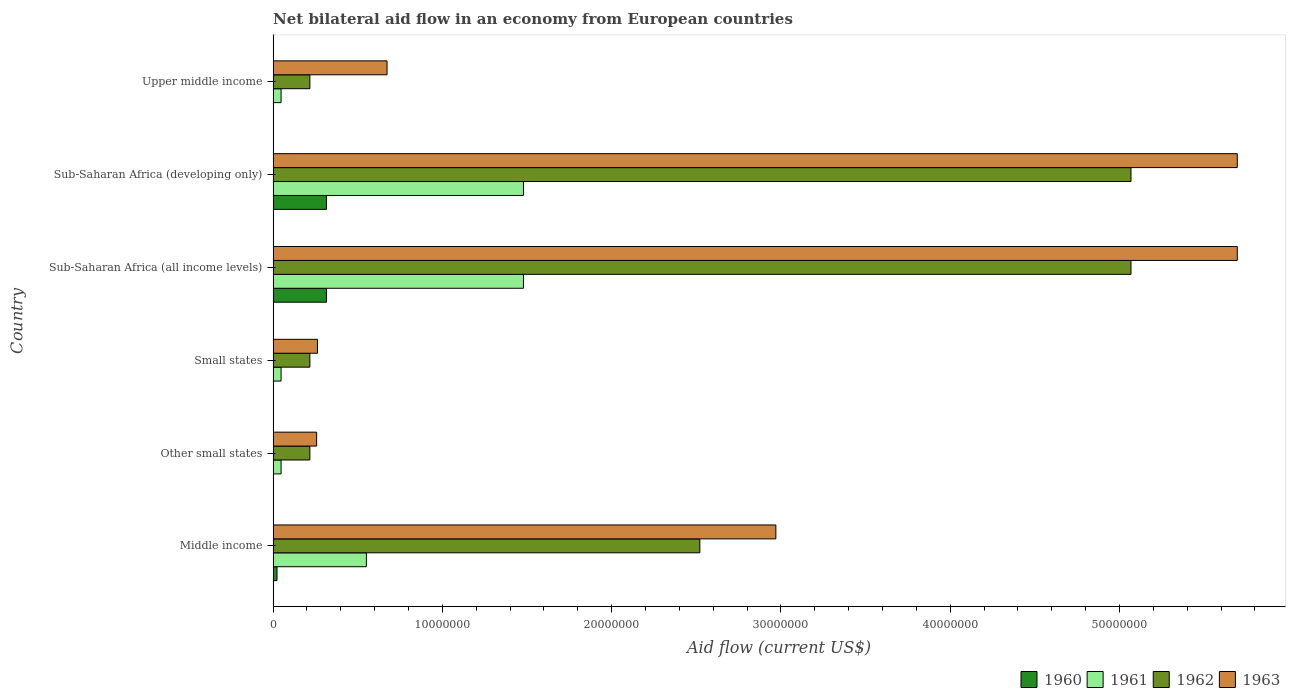How many groups of bars are there?
Give a very brief answer. 6. How many bars are there on the 4th tick from the top?
Give a very brief answer. 4. How many bars are there on the 6th tick from the bottom?
Ensure brevity in your answer.  4. What is the label of the 3rd group of bars from the top?
Offer a terse response. Sub-Saharan Africa (all income levels). In how many cases, is the number of bars for a given country not equal to the number of legend labels?
Your answer should be very brief. 0. What is the net bilateral aid flow in 1963 in Upper middle income?
Give a very brief answer. 6.73e+06. Across all countries, what is the maximum net bilateral aid flow in 1963?
Your response must be concise. 5.70e+07. Across all countries, what is the minimum net bilateral aid flow in 1963?
Provide a succinct answer. 2.57e+06. In which country was the net bilateral aid flow in 1960 maximum?
Provide a succinct answer. Sub-Saharan Africa (all income levels). In which country was the net bilateral aid flow in 1962 minimum?
Offer a terse response. Other small states. What is the total net bilateral aid flow in 1962 in the graph?
Ensure brevity in your answer.  1.33e+08. What is the difference between the net bilateral aid flow in 1960 in Middle income and that in Small states?
Give a very brief answer. 2.20e+05. What is the difference between the net bilateral aid flow in 1960 in Sub-Saharan Africa (all income levels) and the net bilateral aid flow in 1963 in Middle income?
Give a very brief answer. -2.66e+07. What is the average net bilateral aid flow in 1960 per country?
Offer a terse response. 1.09e+06. What is the difference between the net bilateral aid flow in 1962 and net bilateral aid flow in 1961 in Small states?
Provide a short and direct response. 1.70e+06. In how many countries, is the net bilateral aid flow in 1963 greater than 30000000 US$?
Your answer should be very brief. 2. What is the ratio of the net bilateral aid flow in 1963 in Other small states to that in Sub-Saharan Africa (all income levels)?
Offer a terse response. 0.05. Is the net bilateral aid flow in 1963 in Other small states less than that in Upper middle income?
Offer a very short reply. Yes. What is the difference between the highest and the second highest net bilateral aid flow in 1961?
Offer a very short reply. 0. What is the difference between the highest and the lowest net bilateral aid flow in 1963?
Offer a very short reply. 5.44e+07. In how many countries, is the net bilateral aid flow in 1960 greater than the average net bilateral aid flow in 1960 taken over all countries?
Provide a short and direct response. 2. Is the sum of the net bilateral aid flow in 1961 in Middle income and Other small states greater than the maximum net bilateral aid flow in 1960 across all countries?
Your answer should be compact. Yes. Is it the case that in every country, the sum of the net bilateral aid flow in 1961 and net bilateral aid flow in 1963 is greater than the sum of net bilateral aid flow in 1962 and net bilateral aid flow in 1960?
Give a very brief answer. No. What does the 2nd bar from the bottom in Upper middle income represents?
Give a very brief answer. 1961. Is it the case that in every country, the sum of the net bilateral aid flow in 1963 and net bilateral aid flow in 1962 is greater than the net bilateral aid flow in 1960?
Your answer should be compact. Yes. How many bars are there?
Keep it short and to the point. 24. Are all the bars in the graph horizontal?
Offer a very short reply. Yes. Are the values on the major ticks of X-axis written in scientific E-notation?
Keep it short and to the point. No. Does the graph contain grids?
Keep it short and to the point. No. Where does the legend appear in the graph?
Give a very brief answer. Bottom right. What is the title of the graph?
Offer a terse response. Net bilateral aid flow in an economy from European countries. Does "1979" appear as one of the legend labels in the graph?
Keep it short and to the point. No. What is the label or title of the X-axis?
Your answer should be compact. Aid flow (current US$). What is the label or title of the Y-axis?
Give a very brief answer. Country. What is the Aid flow (current US$) of 1960 in Middle income?
Make the answer very short. 2.30e+05. What is the Aid flow (current US$) of 1961 in Middle income?
Your response must be concise. 5.51e+06. What is the Aid flow (current US$) of 1962 in Middle income?
Provide a short and direct response. 2.52e+07. What is the Aid flow (current US$) of 1963 in Middle income?
Offer a very short reply. 2.97e+07. What is the Aid flow (current US$) of 1960 in Other small states?
Provide a succinct answer. 10000. What is the Aid flow (current US$) in 1962 in Other small states?
Give a very brief answer. 2.17e+06. What is the Aid flow (current US$) of 1963 in Other small states?
Offer a terse response. 2.57e+06. What is the Aid flow (current US$) of 1962 in Small states?
Your response must be concise. 2.17e+06. What is the Aid flow (current US$) in 1963 in Small states?
Provide a short and direct response. 2.62e+06. What is the Aid flow (current US$) in 1960 in Sub-Saharan Africa (all income levels)?
Make the answer very short. 3.15e+06. What is the Aid flow (current US$) of 1961 in Sub-Saharan Africa (all income levels)?
Keep it short and to the point. 1.48e+07. What is the Aid flow (current US$) of 1962 in Sub-Saharan Africa (all income levels)?
Keep it short and to the point. 5.07e+07. What is the Aid flow (current US$) in 1963 in Sub-Saharan Africa (all income levels)?
Your response must be concise. 5.70e+07. What is the Aid flow (current US$) of 1960 in Sub-Saharan Africa (developing only)?
Make the answer very short. 3.15e+06. What is the Aid flow (current US$) in 1961 in Sub-Saharan Africa (developing only)?
Ensure brevity in your answer.  1.48e+07. What is the Aid flow (current US$) of 1962 in Sub-Saharan Africa (developing only)?
Offer a very short reply. 5.07e+07. What is the Aid flow (current US$) of 1963 in Sub-Saharan Africa (developing only)?
Offer a very short reply. 5.70e+07. What is the Aid flow (current US$) of 1961 in Upper middle income?
Offer a terse response. 4.70e+05. What is the Aid flow (current US$) in 1962 in Upper middle income?
Your answer should be very brief. 2.17e+06. What is the Aid flow (current US$) of 1963 in Upper middle income?
Ensure brevity in your answer.  6.73e+06. Across all countries, what is the maximum Aid flow (current US$) of 1960?
Offer a terse response. 3.15e+06. Across all countries, what is the maximum Aid flow (current US$) in 1961?
Keep it short and to the point. 1.48e+07. Across all countries, what is the maximum Aid flow (current US$) of 1962?
Give a very brief answer. 5.07e+07. Across all countries, what is the maximum Aid flow (current US$) of 1963?
Ensure brevity in your answer.  5.70e+07. Across all countries, what is the minimum Aid flow (current US$) of 1961?
Give a very brief answer. 4.70e+05. Across all countries, what is the minimum Aid flow (current US$) of 1962?
Give a very brief answer. 2.17e+06. Across all countries, what is the minimum Aid flow (current US$) of 1963?
Offer a terse response. 2.57e+06. What is the total Aid flow (current US$) of 1960 in the graph?
Provide a short and direct response. 6.56e+06. What is the total Aid flow (current US$) of 1961 in the graph?
Offer a very short reply. 3.65e+07. What is the total Aid flow (current US$) in 1962 in the graph?
Offer a terse response. 1.33e+08. What is the total Aid flow (current US$) in 1963 in the graph?
Provide a succinct answer. 1.56e+08. What is the difference between the Aid flow (current US$) of 1960 in Middle income and that in Other small states?
Offer a terse response. 2.20e+05. What is the difference between the Aid flow (current US$) in 1961 in Middle income and that in Other small states?
Your answer should be compact. 5.04e+06. What is the difference between the Aid flow (current US$) in 1962 in Middle income and that in Other small states?
Ensure brevity in your answer.  2.30e+07. What is the difference between the Aid flow (current US$) in 1963 in Middle income and that in Other small states?
Make the answer very short. 2.71e+07. What is the difference between the Aid flow (current US$) of 1961 in Middle income and that in Small states?
Your answer should be very brief. 5.04e+06. What is the difference between the Aid flow (current US$) of 1962 in Middle income and that in Small states?
Offer a very short reply. 2.30e+07. What is the difference between the Aid flow (current US$) in 1963 in Middle income and that in Small states?
Make the answer very short. 2.71e+07. What is the difference between the Aid flow (current US$) in 1960 in Middle income and that in Sub-Saharan Africa (all income levels)?
Make the answer very short. -2.92e+06. What is the difference between the Aid flow (current US$) of 1961 in Middle income and that in Sub-Saharan Africa (all income levels)?
Your response must be concise. -9.28e+06. What is the difference between the Aid flow (current US$) of 1962 in Middle income and that in Sub-Saharan Africa (all income levels)?
Ensure brevity in your answer.  -2.55e+07. What is the difference between the Aid flow (current US$) in 1963 in Middle income and that in Sub-Saharan Africa (all income levels)?
Keep it short and to the point. -2.73e+07. What is the difference between the Aid flow (current US$) of 1960 in Middle income and that in Sub-Saharan Africa (developing only)?
Provide a short and direct response. -2.92e+06. What is the difference between the Aid flow (current US$) of 1961 in Middle income and that in Sub-Saharan Africa (developing only)?
Offer a very short reply. -9.28e+06. What is the difference between the Aid flow (current US$) of 1962 in Middle income and that in Sub-Saharan Africa (developing only)?
Ensure brevity in your answer.  -2.55e+07. What is the difference between the Aid flow (current US$) in 1963 in Middle income and that in Sub-Saharan Africa (developing only)?
Offer a very short reply. -2.73e+07. What is the difference between the Aid flow (current US$) in 1961 in Middle income and that in Upper middle income?
Keep it short and to the point. 5.04e+06. What is the difference between the Aid flow (current US$) of 1962 in Middle income and that in Upper middle income?
Make the answer very short. 2.30e+07. What is the difference between the Aid flow (current US$) in 1963 in Middle income and that in Upper middle income?
Provide a succinct answer. 2.30e+07. What is the difference between the Aid flow (current US$) in 1960 in Other small states and that in Small states?
Make the answer very short. 0. What is the difference between the Aid flow (current US$) in 1962 in Other small states and that in Small states?
Your answer should be very brief. 0. What is the difference between the Aid flow (current US$) in 1963 in Other small states and that in Small states?
Offer a very short reply. -5.00e+04. What is the difference between the Aid flow (current US$) in 1960 in Other small states and that in Sub-Saharan Africa (all income levels)?
Your response must be concise. -3.14e+06. What is the difference between the Aid flow (current US$) in 1961 in Other small states and that in Sub-Saharan Africa (all income levels)?
Keep it short and to the point. -1.43e+07. What is the difference between the Aid flow (current US$) in 1962 in Other small states and that in Sub-Saharan Africa (all income levels)?
Offer a very short reply. -4.85e+07. What is the difference between the Aid flow (current US$) of 1963 in Other small states and that in Sub-Saharan Africa (all income levels)?
Ensure brevity in your answer.  -5.44e+07. What is the difference between the Aid flow (current US$) in 1960 in Other small states and that in Sub-Saharan Africa (developing only)?
Your answer should be very brief. -3.14e+06. What is the difference between the Aid flow (current US$) of 1961 in Other small states and that in Sub-Saharan Africa (developing only)?
Provide a succinct answer. -1.43e+07. What is the difference between the Aid flow (current US$) of 1962 in Other small states and that in Sub-Saharan Africa (developing only)?
Your response must be concise. -4.85e+07. What is the difference between the Aid flow (current US$) of 1963 in Other small states and that in Sub-Saharan Africa (developing only)?
Make the answer very short. -5.44e+07. What is the difference between the Aid flow (current US$) of 1963 in Other small states and that in Upper middle income?
Your answer should be compact. -4.16e+06. What is the difference between the Aid flow (current US$) of 1960 in Small states and that in Sub-Saharan Africa (all income levels)?
Provide a succinct answer. -3.14e+06. What is the difference between the Aid flow (current US$) in 1961 in Small states and that in Sub-Saharan Africa (all income levels)?
Make the answer very short. -1.43e+07. What is the difference between the Aid flow (current US$) in 1962 in Small states and that in Sub-Saharan Africa (all income levels)?
Your answer should be very brief. -4.85e+07. What is the difference between the Aid flow (current US$) of 1963 in Small states and that in Sub-Saharan Africa (all income levels)?
Offer a terse response. -5.43e+07. What is the difference between the Aid flow (current US$) of 1960 in Small states and that in Sub-Saharan Africa (developing only)?
Make the answer very short. -3.14e+06. What is the difference between the Aid flow (current US$) of 1961 in Small states and that in Sub-Saharan Africa (developing only)?
Your response must be concise. -1.43e+07. What is the difference between the Aid flow (current US$) in 1962 in Small states and that in Sub-Saharan Africa (developing only)?
Ensure brevity in your answer.  -4.85e+07. What is the difference between the Aid flow (current US$) in 1963 in Small states and that in Sub-Saharan Africa (developing only)?
Keep it short and to the point. -5.43e+07. What is the difference between the Aid flow (current US$) in 1960 in Small states and that in Upper middle income?
Offer a very short reply. 0. What is the difference between the Aid flow (current US$) in 1961 in Small states and that in Upper middle income?
Keep it short and to the point. 0. What is the difference between the Aid flow (current US$) of 1963 in Small states and that in Upper middle income?
Your answer should be compact. -4.11e+06. What is the difference between the Aid flow (current US$) in 1961 in Sub-Saharan Africa (all income levels) and that in Sub-Saharan Africa (developing only)?
Your answer should be compact. 0. What is the difference between the Aid flow (current US$) of 1962 in Sub-Saharan Africa (all income levels) and that in Sub-Saharan Africa (developing only)?
Ensure brevity in your answer.  0. What is the difference between the Aid flow (current US$) of 1963 in Sub-Saharan Africa (all income levels) and that in Sub-Saharan Africa (developing only)?
Give a very brief answer. 0. What is the difference between the Aid flow (current US$) in 1960 in Sub-Saharan Africa (all income levels) and that in Upper middle income?
Offer a terse response. 3.14e+06. What is the difference between the Aid flow (current US$) of 1961 in Sub-Saharan Africa (all income levels) and that in Upper middle income?
Ensure brevity in your answer.  1.43e+07. What is the difference between the Aid flow (current US$) of 1962 in Sub-Saharan Africa (all income levels) and that in Upper middle income?
Give a very brief answer. 4.85e+07. What is the difference between the Aid flow (current US$) in 1963 in Sub-Saharan Africa (all income levels) and that in Upper middle income?
Keep it short and to the point. 5.02e+07. What is the difference between the Aid flow (current US$) in 1960 in Sub-Saharan Africa (developing only) and that in Upper middle income?
Offer a very short reply. 3.14e+06. What is the difference between the Aid flow (current US$) in 1961 in Sub-Saharan Africa (developing only) and that in Upper middle income?
Provide a succinct answer. 1.43e+07. What is the difference between the Aid flow (current US$) in 1962 in Sub-Saharan Africa (developing only) and that in Upper middle income?
Keep it short and to the point. 4.85e+07. What is the difference between the Aid flow (current US$) in 1963 in Sub-Saharan Africa (developing only) and that in Upper middle income?
Your response must be concise. 5.02e+07. What is the difference between the Aid flow (current US$) in 1960 in Middle income and the Aid flow (current US$) in 1961 in Other small states?
Offer a terse response. -2.40e+05. What is the difference between the Aid flow (current US$) of 1960 in Middle income and the Aid flow (current US$) of 1962 in Other small states?
Ensure brevity in your answer.  -1.94e+06. What is the difference between the Aid flow (current US$) in 1960 in Middle income and the Aid flow (current US$) in 1963 in Other small states?
Offer a very short reply. -2.34e+06. What is the difference between the Aid flow (current US$) of 1961 in Middle income and the Aid flow (current US$) of 1962 in Other small states?
Ensure brevity in your answer.  3.34e+06. What is the difference between the Aid flow (current US$) in 1961 in Middle income and the Aid flow (current US$) in 1963 in Other small states?
Ensure brevity in your answer.  2.94e+06. What is the difference between the Aid flow (current US$) in 1962 in Middle income and the Aid flow (current US$) in 1963 in Other small states?
Your answer should be compact. 2.26e+07. What is the difference between the Aid flow (current US$) of 1960 in Middle income and the Aid flow (current US$) of 1962 in Small states?
Provide a succinct answer. -1.94e+06. What is the difference between the Aid flow (current US$) of 1960 in Middle income and the Aid flow (current US$) of 1963 in Small states?
Your answer should be compact. -2.39e+06. What is the difference between the Aid flow (current US$) in 1961 in Middle income and the Aid flow (current US$) in 1962 in Small states?
Give a very brief answer. 3.34e+06. What is the difference between the Aid flow (current US$) of 1961 in Middle income and the Aid flow (current US$) of 1963 in Small states?
Your response must be concise. 2.89e+06. What is the difference between the Aid flow (current US$) in 1962 in Middle income and the Aid flow (current US$) in 1963 in Small states?
Offer a very short reply. 2.26e+07. What is the difference between the Aid flow (current US$) in 1960 in Middle income and the Aid flow (current US$) in 1961 in Sub-Saharan Africa (all income levels)?
Provide a short and direct response. -1.46e+07. What is the difference between the Aid flow (current US$) in 1960 in Middle income and the Aid flow (current US$) in 1962 in Sub-Saharan Africa (all income levels)?
Offer a terse response. -5.04e+07. What is the difference between the Aid flow (current US$) of 1960 in Middle income and the Aid flow (current US$) of 1963 in Sub-Saharan Africa (all income levels)?
Offer a terse response. -5.67e+07. What is the difference between the Aid flow (current US$) in 1961 in Middle income and the Aid flow (current US$) in 1962 in Sub-Saharan Africa (all income levels)?
Provide a succinct answer. -4.52e+07. What is the difference between the Aid flow (current US$) of 1961 in Middle income and the Aid flow (current US$) of 1963 in Sub-Saharan Africa (all income levels)?
Provide a short and direct response. -5.14e+07. What is the difference between the Aid flow (current US$) in 1962 in Middle income and the Aid flow (current US$) in 1963 in Sub-Saharan Africa (all income levels)?
Your response must be concise. -3.18e+07. What is the difference between the Aid flow (current US$) in 1960 in Middle income and the Aid flow (current US$) in 1961 in Sub-Saharan Africa (developing only)?
Your response must be concise. -1.46e+07. What is the difference between the Aid flow (current US$) of 1960 in Middle income and the Aid flow (current US$) of 1962 in Sub-Saharan Africa (developing only)?
Keep it short and to the point. -5.04e+07. What is the difference between the Aid flow (current US$) in 1960 in Middle income and the Aid flow (current US$) in 1963 in Sub-Saharan Africa (developing only)?
Your answer should be compact. -5.67e+07. What is the difference between the Aid flow (current US$) in 1961 in Middle income and the Aid flow (current US$) in 1962 in Sub-Saharan Africa (developing only)?
Provide a succinct answer. -4.52e+07. What is the difference between the Aid flow (current US$) of 1961 in Middle income and the Aid flow (current US$) of 1963 in Sub-Saharan Africa (developing only)?
Offer a very short reply. -5.14e+07. What is the difference between the Aid flow (current US$) of 1962 in Middle income and the Aid flow (current US$) of 1963 in Sub-Saharan Africa (developing only)?
Your answer should be compact. -3.18e+07. What is the difference between the Aid flow (current US$) in 1960 in Middle income and the Aid flow (current US$) in 1961 in Upper middle income?
Keep it short and to the point. -2.40e+05. What is the difference between the Aid flow (current US$) of 1960 in Middle income and the Aid flow (current US$) of 1962 in Upper middle income?
Your answer should be very brief. -1.94e+06. What is the difference between the Aid flow (current US$) in 1960 in Middle income and the Aid flow (current US$) in 1963 in Upper middle income?
Your response must be concise. -6.50e+06. What is the difference between the Aid flow (current US$) in 1961 in Middle income and the Aid flow (current US$) in 1962 in Upper middle income?
Offer a terse response. 3.34e+06. What is the difference between the Aid flow (current US$) of 1961 in Middle income and the Aid flow (current US$) of 1963 in Upper middle income?
Give a very brief answer. -1.22e+06. What is the difference between the Aid flow (current US$) of 1962 in Middle income and the Aid flow (current US$) of 1963 in Upper middle income?
Your answer should be compact. 1.85e+07. What is the difference between the Aid flow (current US$) of 1960 in Other small states and the Aid flow (current US$) of 1961 in Small states?
Ensure brevity in your answer.  -4.60e+05. What is the difference between the Aid flow (current US$) in 1960 in Other small states and the Aid flow (current US$) in 1962 in Small states?
Offer a terse response. -2.16e+06. What is the difference between the Aid flow (current US$) of 1960 in Other small states and the Aid flow (current US$) of 1963 in Small states?
Your answer should be compact. -2.61e+06. What is the difference between the Aid flow (current US$) in 1961 in Other small states and the Aid flow (current US$) in 1962 in Small states?
Your response must be concise. -1.70e+06. What is the difference between the Aid flow (current US$) in 1961 in Other small states and the Aid flow (current US$) in 1963 in Small states?
Give a very brief answer. -2.15e+06. What is the difference between the Aid flow (current US$) in 1962 in Other small states and the Aid flow (current US$) in 1963 in Small states?
Provide a succinct answer. -4.50e+05. What is the difference between the Aid flow (current US$) of 1960 in Other small states and the Aid flow (current US$) of 1961 in Sub-Saharan Africa (all income levels)?
Your answer should be very brief. -1.48e+07. What is the difference between the Aid flow (current US$) in 1960 in Other small states and the Aid flow (current US$) in 1962 in Sub-Saharan Africa (all income levels)?
Provide a succinct answer. -5.07e+07. What is the difference between the Aid flow (current US$) in 1960 in Other small states and the Aid flow (current US$) in 1963 in Sub-Saharan Africa (all income levels)?
Keep it short and to the point. -5.70e+07. What is the difference between the Aid flow (current US$) of 1961 in Other small states and the Aid flow (current US$) of 1962 in Sub-Saharan Africa (all income levels)?
Offer a terse response. -5.02e+07. What is the difference between the Aid flow (current US$) in 1961 in Other small states and the Aid flow (current US$) in 1963 in Sub-Saharan Africa (all income levels)?
Keep it short and to the point. -5.65e+07. What is the difference between the Aid flow (current US$) in 1962 in Other small states and the Aid flow (current US$) in 1963 in Sub-Saharan Africa (all income levels)?
Provide a short and direct response. -5.48e+07. What is the difference between the Aid flow (current US$) in 1960 in Other small states and the Aid flow (current US$) in 1961 in Sub-Saharan Africa (developing only)?
Your answer should be very brief. -1.48e+07. What is the difference between the Aid flow (current US$) of 1960 in Other small states and the Aid flow (current US$) of 1962 in Sub-Saharan Africa (developing only)?
Your response must be concise. -5.07e+07. What is the difference between the Aid flow (current US$) of 1960 in Other small states and the Aid flow (current US$) of 1963 in Sub-Saharan Africa (developing only)?
Offer a very short reply. -5.70e+07. What is the difference between the Aid flow (current US$) of 1961 in Other small states and the Aid flow (current US$) of 1962 in Sub-Saharan Africa (developing only)?
Offer a very short reply. -5.02e+07. What is the difference between the Aid flow (current US$) in 1961 in Other small states and the Aid flow (current US$) in 1963 in Sub-Saharan Africa (developing only)?
Your response must be concise. -5.65e+07. What is the difference between the Aid flow (current US$) of 1962 in Other small states and the Aid flow (current US$) of 1963 in Sub-Saharan Africa (developing only)?
Give a very brief answer. -5.48e+07. What is the difference between the Aid flow (current US$) of 1960 in Other small states and the Aid flow (current US$) of 1961 in Upper middle income?
Provide a short and direct response. -4.60e+05. What is the difference between the Aid flow (current US$) of 1960 in Other small states and the Aid flow (current US$) of 1962 in Upper middle income?
Your answer should be compact. -2.16e+06. What is the difference between the Aid flow (current US$) of 1960 in Other small states and the Aid flow (current US$) of 1963 in Upper middle income?
Keep it short and to the point. -6.72e+06. What is the difference between the Aid flow (current US$) of 1961 in Other small states and the Aid flow (current US$) of 1962 in Upper middle income?
Ensure brevity in your answer.  -1.70e+06. What is the difference between the Aid flow (current US$) of 1961 in Other small states and the Aid flow (current US$) of 1963 in Upper middle income?
Offer a very short reply. -6.26e+06. What is the difference between the Aid flow (current US$) in 1962 in Other small states and the Aid flow (current US$) in 1963 in Upper middle income?
Provide a short and direct response. -4.56e+06. What is the difference between the Aid flow (current US$) in 1960 in Small states and the Aid flow (current US$) in 1961 in Sub-Saharan Africa (all income levels)?
Your response must be concise. -1.48e+07. What is the difference between the Aid flow (current US$) in 1960 in Small states and the Aid flow (current US$) in 1962 in Sub-Saharan Africa (all income levels)?
Provide a short and direct response. -5.07e+07. What is the difference between the Aid flow (current US$) of 1960 in Small states and the Aid flow (current US$) of 1963 in Sub-Saharan Africa (all income levels)?
Keep it short and to the point. -5.70e+07. What is the difference between the Aid flow (current US$) in 1961 in Small states and the Aid flow (current US$) in 1962 in Sub-Saharan Africa (all income levels)?
Provide a short and direct response. -5.02e+07. What is the difference between the Aid flow (current US$) of 1961 in Small states and the Aid flow (current US$) of 1963 in Sub-Saharan Africa (all income levels)?
Give a very brief answer. -5.65e+07. What is the difference between the Aid flow (current US$) of 1962 in Small states and the Aid flow (current US$) of 1963 in Sub-Saharan Africa (all income levels)?
Ensure brevity in your answer.  -5.48e+07. What is the difference between the Aid flow (current US$) of 1960 in Small states and the Aid flow (current US$) of 1961 in Sub-Saharan Africa (developing only)?
Ensure brevity in your answer.  -1.48e+07. What is the difference between the Aid flow (current US$) of 1960 in Small states and the Aid flow (current US$) of 1962 in Sub-Saharan Africa (developing only)?
Provide a succinct answer. -5.07e+07. What is the difference between the Aid flow (current US$) of 1960 in Small states and the Aid flow (current US$) of 1963 in Sub-Saharan Africa (developing only)?
Give a very brief answer. -5.70e+07. What is the difference between the Aid flow (current US$) in 1961 in Small states and the Aid flow (current US$) in 1962 in Sub-Saharan Africa (developing only)?
Give a very brief answer. -5.02e+07. What is the difference between the Aid flow (current US$) in 1961 in Small states and the Aid flow (current US$) in 1963 in Sub-Saharan Africa (developing only)?
Offer a very short reply. -5.65e+07. What is the difference between the Aid flow (current US$) of 1962 in Small states and the Aid flow (current US$) of 1963 in Sub-Saharan Africa (developing only)?
Make the answer very short. -5.48e+07. What is the difference between the Aid flow (current US$) in 1960 in Small states and the Aid flow (current US$) in 1961 in Upper middle income?
Offer a terse response. -4.60e+05. What is the difference between the Aid flow (current US$) of 1960 in Small states and the Aid flow (current US$) of 1962 in Upper middle income?
Your answer should be very brief. -2.16e+06. What is the difference between the Aid flow (current US$) in 1960 in Small states and the Aid flow (current US$) in 1963 in Upper middle income?
Offer a terse response. -6.72e+06. What is the difference between the Aid flow (current US$) of 1961 in Small states and the Aid flow (current US$) of 1962 in Upper middle income?
Your answer should be compact. -1.70e+06. What is the difference between the Aid flow (current US$) of 1961 in Small states and the Aid flow (current US$) of 1963 in Upper middle income?
Offer a terse response. -6.26e+06. What is the difference between the Aid flow (current US$) in 1962 in Small states and the Aid flow (current US$) in 1963 in Upper middle income?
Keep it short and to the point. -4.56e+06. What is the difference between the Aid flow (current US$) in 1960 in Sub-Saharan Africa (all income levels) and the Aid flow (current US$) in 1961 in Sub-Saharan Africa (developing only)?
Offer a terse response. -1.16e+07. What is the difference between the Aid flow (current US$) in 1960 in Sub-Saharan Africa (all income levels) and the Aid flow (current US$) in 1962 in Sub-Saharan Africa (developing only)?
Keep it short and to the point. -4.75e+07. What is the difference between the Aid flow (current US$) in 1960 in Sub-Saharan Africa (all income levels) and the Aid flow (current US$) in 1963 in Sub-Saharan Africa (developing only)?
Your response must be concise. -5.38e+07. What is the difference between the Aid flow (current US$) in 1961 in Sub-Saharan Africa (all income levels) and the Aid flow (current US$) in 1962 in Sub-Saharan Africa (developing only)?
Provide a short and direct response. -3.59e+07. What is the difference between the Aid flow (current US$) of 1961 in Sub-Saharan Africa (all income levels) and the Aid flow (current US$) of 1963 in Sub-Saharan Africa (developing only)?
Make the answer very short. -4.22e+07. What is the difference between the Aid flow (current US$) in 1962 in Sub-Saharan Africa (all income levels) and the Aid flow (current US$) in 1963 in Sub-Saharan Africa (developing only)?
Ensure brevity in your answer.  -6.28e+06. What is the difference between the Aid flow (current US$) of 1960 in Sub-Saharan Africa (all income levels) and the Aid flow (current US$) of 1961 in Upper middle income?
Your response must be concise. 2.68e+06. What is the difference between the Aid flow (current US$) of 1960 in Sub-Saharan Africa (all income levels) and the Aid flow (current US$) of 1962 in Upper middle income?
Provide a succinct answer. 9.80e+05. What is the difference between the Aid flow (current US$) of 1960 in Sub-Saharan Africa (all income levels) and the Aid flow (current US$) of 1963 in Upper middle income?
Your answer should be very brief. -3.58e+06. What is the difference between the Aid flow (current US$) of 1961 in Sub-Saharan Africa (all income levels) and the Aid flow (current US$) of 1962 in Upper middle income?
Give a very brief answer. 1.26e+07. What is the difference between the Aid flow (current US$) in 1961 in Sub-Saharan Africa (all income levels) and the Aid flow (current US$) in 1963 in Upper middle income?
Make the answer very short. 8.06e+06. What is the difference between the Aid flow (current US$) of 1962 in Sub-Saharan Africa (all income levels) and the Aid flow (current US$) of 1963 in Upper middle income?
Provide a short and direct response. 4.40e+07. What is the difference between the Aid flow (current US$) in 1960 in Sub-Saharan Africa (developing only) and the Aid flow (current US$) in 1961 in Upper middle income?
Keep it short and to the point. 2.68e+06. What is the difference between the Aid flow (current US$) of 1960 in Sub-Saharan Africa (developing only) and the Aid flow (current US$) of 1962 in Upper middle income?
Offer a very short reply. 9.80e+05. What is the difference between the Aid flow (current US$) of 1960 in Sub-Saharan Africa (developing only) and the Aid flow (current US$) of 1963 in Upper middle income?
Keep it short and to the point. -3.58e+06. What is the difference between the Aid flow (current US$) in 1961 in Sub-Saharan Africa (developing only) and the Aid flow (current US$) in 1962 in Upper middle income?
Keep it short and to the point. 1.26e+07. What is the difference between the Aid flow (current US$) of 1961 in Sub-Saharan Africa (developing only) and the Aid flow (current US$) of 1963 in Upper middle income?
Give a very brief answer. 8.06e+06. What is the difference between the Aid flow (current US$) in 1962 in Sub-Saharan Africa (developing only) and the Aid flow (current US$) in 1963 in Upper middle income?
Your answer should be compact. 4.40e+07. What is the average Aid flow (current US$) of 1960 per country?
Provide a succinct answer. 1.09e+06. What is the average Aid flow (current US$) in 1961 per country?
Your response must be concise. 6.08e+06. What is the average Aid flow (current US$) in 1962 per country?
Make the answer very short. 2.22e+07. What is the average Aid flow (current US$) in 1963 per country?
Give a very brief answer. 2.59e+07. What is the difference between the Aid flow (current US$) in 1960 and Aid flow (current US$) in 1961 in Middle income?
Your response must be concise. -5.28e+06. What is the difference between the Aid flow (current US$) in 1960 and Aid flow (current US$) in 1962 in Middle income?
Give a very brief answer. -2.50e+07. What is the difference between the Aid flow (current US$) of 1960 and Aid flow (current US$) of 1963 in Middle income?
Your response must be concise. -2.95e+07. What is the difference between the Aid flow (current US$) in 1961 and Aid flow (current US$) in 1962 in Middle income?
Your answer should be very brief. -1.97e+07. What is the difference between the Aid flow (current US$) of 1961 and Aid flow (current US$) of 1963 in Middle income?
Provide a short and direct response. -2.42e+07. What is the difference between the Aid flow (current US$) in 1962 and Aid flow (current US$) in 1963 in Middle income?
Provide a short and direct response. -4.49e+06. What is the difference between the Aid flow (current US$) of 1960 and Aid flow (current US$) of 1961 in Other small states?
Your answer should be compact. -4.60e+05. What is the difference between the Aid flow (current US$) of 1960 and Aid flow (current US$) of 1962 in Other small states?
Your answer should be compact. -2.16e+06. What is the difference between the Aid flow (current US$) of 1960 and Aid flow (current US$) of 1963 in Other small states?
Give a very brief answer. -2.56e+06. What is the difference between the Aid flow (current US$) of 1961 and Aid flow (current US$) of 1962 in Other small states?
Make the answer very short. -1.70e+06. What is the difference between the Aid flow (current US$) in 1961 and Aid flow (current US$) in 1963 in Other small states?
Give a very brief answer. -2.10e+06. What is the difference between the Aid flow (current US$) of 1962 and Aid flow (current US$) of 1963 in Other small states?
Offer a very short reply. -4.00e+05. What is the difference between the Aid flow (current US$) of 1960 and Aid flow (current US$) of 1961 in Small states?
Your answer should be very brief. -4.60e+05. What is the difference between the Aid flow (current US$) in 1960 and Aid flow (current US$) in 1962 in Small states?
Your response must be concise. -2.16e+06. What is the difference between the Aid flow (current US$) of 1960 and Aid flow (current US$) of 1963 in Small states?
Ensure brevity in your answer.  -2.61e+06. What is the difference between the Aid flow (current US$) of 1961 and Aid flow (current US$) of 1962 in Small states?
Give a very brief answer. -1.70e+06. What is the difference between the Aid flow (current US$) of 1961 and Aid flow (current US$) of 1963 in Small states?
Offer a terse response. -2.15e+06. What is the difference between the Aid flow (current US$) of 1962 and Aid flow (current US$) of 1963 in Small states?
Provide a short and direct response. -4.50e+05. What is the difference between the Aid flow (current US$) of 1960 and Aid flow (current US$) of 1961 in Sub-Saharan Africa (all income levels)?
Offer a terse response. -1.16e+07. What is the difference between the Aid flow (current US$) of 1960 and Aid flow (current US$) of 1962 in Sub-Saharan Africa (all income levels)?
Offer a very short reply. -4.75e+07. What is the difference between the Aid flow (current US$) in 1960 and Aid flow (current US$) in 1963 in Sub-Saharan Africa (all income levels)?
Your response must be concise. -5.38e+07. What is the difference between the Aid flow (current US$) of 1961 and Aid flow (current US$) of 1962 in Sub-Saharan Africa (all income levels)?
Provide a short and direct response. -3.59e+07. What is the difference between the Aid flow (current US$) in 1961 and Aid flow (current US$) in 1963 in Sub-Saharan Africa (all income levels)?
Your answer should be compact. -4.22e+07. What is the difference between the Aid flow (current US$) in 1962 and Aid flow (current US$) in 1963 in Sub-Saharan Africa (all income levels)?
Make the answer very short. -6.28e+06. What is the difference between the Aid flow (current US$) in 1960 and Aid flow (current US$) in 1961 in Sub-Saharan Africa (developing only)?
Provide a short and direct response. -1.16e+07. What is the difference between the Aid flow (current US$) of 1960 and Aid flow (current US$) of 1962 in Sub-Saharan Africa (developing only)?
Keep it short and to the point. -4.75e+07. What is the difference between the Aid flow (current US$) in 1960 and Aid flow (current US$) in 1963 in Sub-Saharan Africa (developing only)?
Offer a very short reply. -5.38e+07. What is the difference between the Aid flow (current US$) in 1961 and Aid flow (current US$) in 1962 in Sub-Saharan Africa (developing only)?
Provide a short and direct response. -3.59e+07. What is the difference between the Aid flow (current US$) in 1961 and Aid flow (current US$) in 1963 in Sub-Saharan Africa (developing only)?
Provide a short and direct response. -4.22e+07. What is the difference between the Aid flow (current US$) of 1962 and Aid flow (current US$) of 1963 in Sub-Saharan Africa (developing only)?
Make the answer very short. -6.28e+06. What is the difference between the Aid flow (current US$) of 1960 and Aid flow (current US$) of 1961 in Upper middle income?
Keep it short and to the point. -4.60e+05. What is the difference between the Aid flow (current US$) in 1960 and Aid flow (current US$) in 1962 in Upper middle income?
Your response must be concise. -2.16e+06. What is the difference between the Aid flow (current US$) in 1960 and Aid flow (current US$) in 1963 in Upper middle income?
Make the answer very short. -6.72e+06. What is the difference between the Aid flow (current US$) of 1961 and Aid flow (current US$) of 1962 in Upper middle income?
Your answer should be very brief. -1.70e+06. What is the difference between the Aid flow (current US$) of 1961 and Aid flow (current US$) of 1963 in Upper middle income?
Give a very brief answer. -6.26e+06. What is the difference between the Aid flow (current US$) of 1962 and Aid flow (current US$) of 1963 in Upper middle income?
Provide a succinct answer. -4.56e+06. What is the ratio of the Aid flow (current US$) of 1960 in Middle income to that in Other small states?
Provide a succinct answer. 23. What is the ratio of the Aid flow (current US$) of 1961 in Middle income to that in Other small states?
Keep it short and to the point. 11.72. What is the ratio of the Aid flow (current US$) of 1962 in Middle income to that in Other small states?
Make the answer very short. 11.62. What is the ratio of the Aid flow (current US$) in 1963 in Middle income to that in Other small states?
Offer a very short reply. 11.56. What is the ratio of the Aid flow (current US$) in 1961 in Middle income to that in Small states?
Ensure brevity in your answer.  11.72. What is the ratio of the Aid flow (current US$) of 1962 in Middle income to that in Small states?
Keep it short and to the point. 11.62. What is the ratio of the Aid flow (current US$) of 1963 in Middle income to that in Small states?
Keep it short and to the point. 11.34. What is the ratio of the Aid flow (current US$) in 1960 in Middle income to that in Sub-Saharan Africa (all income levels)?
Your response must be concise. 0.07. What is the ratio of the Aid flow (current US$) of 1961 in Middle income to that in Sub-Saharan Africa (all income levels)?
Make the answer very short. 0.37. What is the ratio of the Aid flow (current US$) in 1962 in Middle income to that in Sub-Saharan Africa (all income levels)?
Give a very brief answer. 0.5. What is the ratio of the Aid flow (current US$) of 1963 in Middle income to that in Sub-Saharan Africa (all income levels)?
Your response must be concise. 0.52. What is the ratio of the Aid flow (current US$) in 1960 in Middle income to that in Sub-Saharan Africa (developing only)?
Keep it short and to the point. 0.07. What is the ratio of the Aid flow (current US$) of 1961 in Middle income to that in Sub-Saharan Africa (developing only)?
Your answer should be very brief. 0.37. What is the ratio of the Aid flow (current US$) in 1962 in Middle income to that in Sub-Saharan Africa (developing only)?
Offer a very short reply. 0.5. What is the ratio of the Aid flow (current US$) in 1963 in Middle income to that in Sub-Saharan Africa (developing only)?
Your answer should be very brief. 0.52. What is the ratio of the Aid flow (current US$) of 1961 in Middle income to that in Upper middle income?
Your response must be concise. 11.72. What is the ratio of the Aid flow (current US$) in 1962 in Middle income to that in Upper middle income?
Provide a short and direct response. 11.62. What is the ratio of the Aid flow (current US$) of 1963 in Middle income to that in Upper middle income?
Give a very brief answer. 4.41. What is the ratio of the Aid flow (current US$) of 1960 in Other small states to that in Small states?
Offer a very short reply. 1. What is the ratio of the Aid flow (current US$) in 1962 in Other small states to that in Small states?
Provide a short and direct response. 1. What is the ratio of the Aid flow (current US$) of 1963 in Other small states to that in Small states?
Keep it short and to the point. 0.98. What is the ratio of the Aid flow (current US$) of 1960 in Other small states to that in Sub-Saharan Africa (all income levels)?
Provide a succinct answer. 0. What is the ratio of the Aid flow (current US$) in 1961 in Other small states to that in Sub-Saharan Africa (all income levels)?
Provide a succinct answer. 0.03. What is the ratio of the Aid flow (current US$) of 1962 in Other small states to that in Sub-Saharan Africa (all income levels)?
Offer a terse response. 0.04. What is the ratio of the Aid flow (current US$) of 1963 in Other small states to that in Sub-Saharan Africa (all income levels)?
Keep it short and to the point. 0.05. What is the ratio of the Aid flow (current US$) in 1960 in Other small states to that in Sub-Saharan Africa (developing only)?
Make the answer very short. 0. What is the ratio of the Aid flow (current US$) in 1961 in Other small states to that in Sub-Saharan Africa (developing only)?
Ensure brevity in your answer.  0.03. What is the ratio of the Aid flow (current US$) of 1962 in Other small states to that in Sub-Saharan Africa (developing only)?
Your response must be concise. 0.04. What is the ratio of the Aid flow (current US$) in 1963 in Other small states to that in Sub-Saharan Africa (developing only)?
Provide a succinct answer. 0.05. What is the ratio of the Aid flow (current US$) in 1960 in Other small states to that in Upper middle income?
Your answer should be very brief. 1. What is the ratio of the Aid flow (current US$) of 1963 in Other small states to that in Upper middle income?
Provide a succinct answer. 0.38. What is the ratio of the Aid flow (current US$) of 1960 in Small states to that in Sub-Saharan Africa (all income levels)?
Your answer should be very brief. 0. What is the ratio of the Aid flow (current US$) of 1961 in Small states to that in Sub-Saharan Africa (all income levels)?
Your response must be concise. 0.03. What is the ratio of the Aid flow (current US$) in 1962 in Small states to that in Sub-Saharan Africa (all income levels)?
Offer a terse response. 0.04. What is the ratio of the Aid flow (current US$) of 1963 in Small states to that in Sub-Saharan Africa (all income levels)?
Offer a very short reply. 0.05. What is the ratio of the Aid flow (current US$) in 1960 in Small states to that in Sub-Saharan Africa (developing only)?
Your answer should be very brief. 0. What is the ratio of the Aid flow (current US$) in 1961 in Small states to that in Sub-Saharan Africa (developing only)?
Make the answer very short. 0.03. What is the ratio of the Aid flow (current US$) of 1962 in Small states to that in Sub-Saharan Africa (developing only)?
Your answer should be compact. 0.04. What is the ratio of the Aid flow (current US$) in 1963 in Small states to that in Sub-Saharan Africa (developing only)?
Your answer should be compact. 0.05. What is the ratio of the Aid flow (current US$) of 1961 in Small states to that in Upper middle income?
Provide a short and direct response. 1. What is the ratio of the Aid flow (current US$) of 1962 in Small states to that in Upper middle income?
Offer a very short reply. 1. What is the ratio of the Aid flow (current US$) in 1963 in Small states to that in Upper middle income?
Your answer should be very brief. 0.39. What is the ratio of the Aid flow (current US$) in 1960 in Sub-Saharan Africa (all income levels) to that in Sub-Saharan Africa (developing only)?
Your response must be concise. 1. What is the ratio of the Aid flow (current US$) of 1962 in Sub-Saharan Africa (all income levels) to that in Sub-Saharan Africa (developing only)?
Your answer should be very brief. 1. What is the ratio of the Aid flow (current US$) of 1963 in Sub-Saharan Africa (all income levels) to that in Sub-Saharan Africa (developing only)?
Provide a short and direct response. 1. What is the ratio of the Aid flow (current US$) of 1960 in Sub-Saharan Africa (all income levels) to that in Upper middle income?
Your answer should be very brief. 315. What is the ratio of the Aid flow (current US$) in 1961 in Sub-Saharan Africa (all income levels) to that in Upper middle income?
Give a very brief answer. 31.47. What is the ratio of the Aid flow (current US$) in 1962 in Sub-Saharan Africa (all income levels) to that in Upper middle income?
Provide a succinct answer. 23.35. What is the ratio of the Aid flow (current US$) of 1963 in Sub-Saharan Africa (all income levels) to that in Upper middle income?
Offer a very short reply. 8.46. What is the ratio of the Aid flow (current US$) of 1960 in Sub-Saharan Africa (developing only) to that in Upper middle income?
Keep it short and to the point. 315. What is the ratio of the Aid flow (current US$) of 1961 in Sub-Saharan Africa (developing only) to that in Upper middle income?
Your answer should be very brief. 31.47. What is the ratio of the Aid flow (current US$) of 1962 in Sub-Saharan Africa (developing only) to that in Upper middle income?
Offer a very short reply. 23.35. What is the ratio of the Aid flow (current US$) in 1963 in Sub-Saharan Africa (developing only) to that in Upper middle income?
Your answer should be very brief. 8.46. What is the difference between the highest and the second highest Aid flow (current US$) in 1962?
Make the answer very short. 0. What is the difference between the highest and the lowest Aid flow (current US$) of 1960?
Ensure brevity in your answer.  3.14e+06. What is the difference between the highest and the lowest Aid flow (current US$) in 1961?
Keep it short and to the point. 1.43e+07. What is the difference between the highest and the lowest Aid flow (current US$) of 1962?
Offer a terse response. 4.85e+07. What is the difference between the highest and the lowest Aid flow (current US$) in 1963?
Keep it short and to the point. 5.44e+07. 